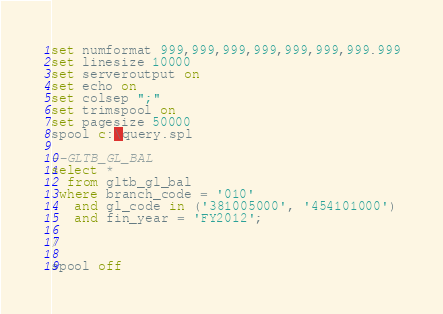Convert code to text. <code><loc_0><loc_0><loc_500><loc_500><_SQL_>set numformat 999,999,999,999,999,999,999.999
set linesize 10000
set serveroutput on
set echo on
set colsep ";"
set trimspool on
set pagesize 50000
spool c:\query.spl

--GLTB_GL_BAL
select *
  from gltb_gl_bal
 where branch_code = '010'
   and gl_code in ('381005000', '454101000')
   and fin_year = 'FY2012';

/

spool off
</code> 